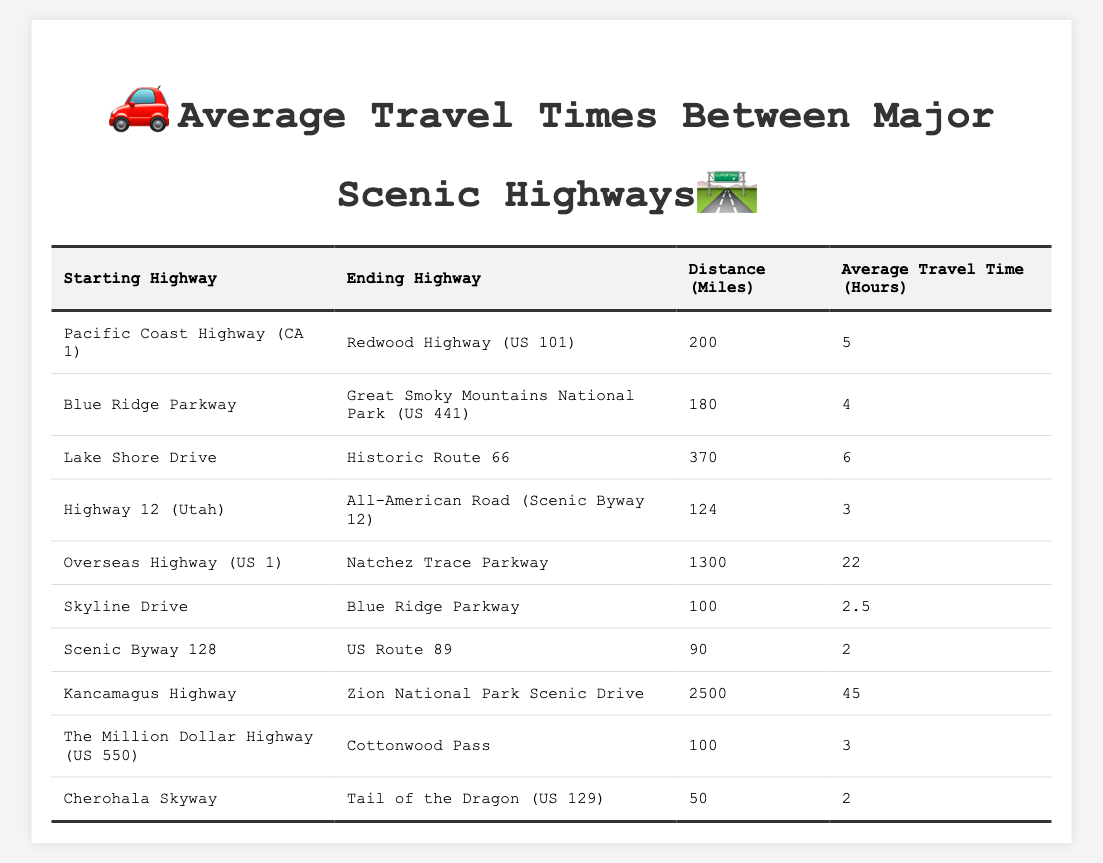What is the average travel time from the Pacific Coast Highway to the Redwood Highway? The table shows that the average travel time from the Pacific Coast Highway (CA 1) to the Redwood Highway (US 101) is 5 hours.
Answer: 5 hours Which two highways have an average travel time of 22 hours? According to the table, the Overseas Highway (US 1) to Natchez Trace Parkway has an average travel time of 22 hours. It is the only route listed with that duration.
Answer: Overseas Highway to Natchez Trace Parkway What is the distance between Lake Shore Drive and Historic Route 66? The table lists the distance between Lake Shore Drive and Historic Route 66 as 370 miles.
Answer: 370 miles Are there any scenic highways with a distance of less than 100 miles? The table shows that there are two scenic highways with distances less than 100 miles: Cherohala Skyway to Tail of the Dragon (US 129) which is 50 miles, and Scenic Byway 128 to US Route 89 which is 90 miles. Therefore, the answer is yes.
Answer: Yes What is the total distance of all scenic routes listed in the table? To find the total distance, we sum all the distance values: 200 + 180 + 370 + 124 + 1300 + 100 + 90 + 2500 + 100 + 50 = 5124 miles.
Answer: 5124 miles Which route has the longest average travel time and what is that time? According to the table, Kancamagus Highway to Zion National Park Scenic Drive has the longest average travel time of 45 hours, which is the highest listed in the table.
Answer: 45 hours What is the difference in average travel time between the shortest and longest routes? The shortest average travel time is for Skyline Drive to Blue Ridge Parkway at 2.5 hours, and the longest is for Kancamagus Highway to Zion National Park Scenic Drive at 45 hours. The difference is 45 - 2.5 = 42.5 hours.
Answer: 42.5 hours Which scenic highway connections take less than 3 hours? The table shows three routes with an average travel time of less than 3 hours: Skyline Drive to Blue Ridge Parkway (2.5 hours), Scenic Byway 128 to US Route 89 (2 hours), and Cherohala Skyway to Tail of the Dragon (US 129) (2 hours).
Answer: 3 routes Is the distance from the Overseas Highway to the Natchez Trace Parkway greater than 1000 miles? Yes, the table reports that the distance from the Overseas Highway (US 1) to Natchez Trace Parkway is 1300 miles, which is indeed greater than 1000 miles.
Answer: Yes What is the average travel time for scenic highways located in the Blue Ridge Parkway area? The routes starting and ending in the Blue Ridge Parkway area are: Blue Ridge Parkway to Great Smoky Mountains National Park (4 hours) and Skyline Drive to Blue Ridge Parkway (2.5 hours). The average is (4 + 2.5) / 2 = 3.25 hours.
Answer: 3.25 hours 